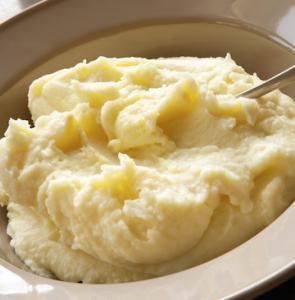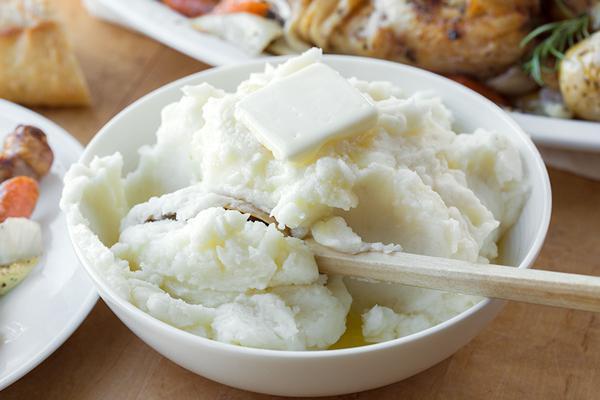The first image is the image on the left, the second image is the image on the right. Examine the images to the left and right. Is the description "There is a spoon laying on the table near the bowl in one image." accurate? Answer yes or no. No. The first image is the image on the left, the second image is the image on the right. For the images shown, is this caption "A spoon is sitting outside of the bowl of food in one of the images." true? Answer yes or no. No. 